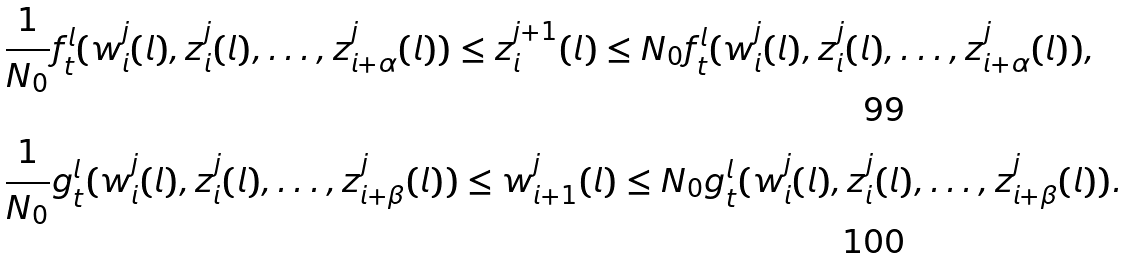<formula> <loc_0><loc_0><loc_500><loc_500>& \frac { 1 } { N _ { 0 } } f ^ { l } _ { t } ( w _ { i } ^ { j } ( l ) , z _ { i } ^ { j } ( l ) , \dots , z _ { i + \alpha } ^ { j } ( l ) ) \leq z _ { i } ^ { j + 1 } ( l ) \leq N _ { 0 } f ^ { l } _ { t } ( w _ { i } ^ { j } ( l ) , z _ { i } ^ { j } ( l ) , \dots , z _ { i + \alpha } ^ { j } ( l ) ) , \\ & \frac { 1 } { N _ { 0 } } g ^ { l } _ { t } ( w _ { i } ^ { j } ( l ) , z _ { i } ^ { j } ( l ) , \dots , z _ { i + \beta } ^ { j } ( l ) ) \leq w _ { i + 1 } ^ { j } ( l ) \leq N _ { 0 } g ^ { l } _ { t } ( w _ { i } ^ { j } ( l ) , z _ { i } ^ { j } ( l ) , \dots , z _ { i + \beta } ^ { j } ( l ) ) .</formula> 